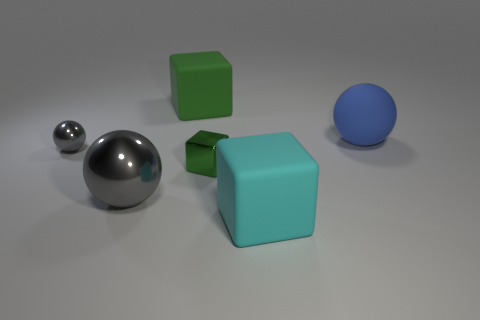There is another large object that is the same shape as the blue matte thing; what color is it?
Your answer should be compact. Gray. The gray thing to the left of the gray metallic thing on the right side of the small metal thing that is to the left of the big green thing is what shape?
Offer a very short reply. Sphere. How big is the thing that is both to the left of the large blue object and behind the small gray ball?
Give a very brief answer. Large. Are there fewer large matte things than large blocks?
Give a very brief answer. No. There is a metal ball that is left of the big shiny object; what is its size?
Your answer should be very brief. Small. What shape is the large rubber thing that is both behind the cyan rubber thing and to the left of the blue matte sphere?
Your response must be concise. Cube. The green shiny thing that is the same shape as the big green rubber object is what size?
Give a very brief answer. Small. How many small cyan spheres are made of the same material as the small green block?
Your response must be concise. 0. There is a tiny metallic block; does it have the same color as the matte object behind the big matte ball?
Provide a short and direct response. Yes. Are there more large yellow blocks than big cyan things?
Offer a terse response. No. 